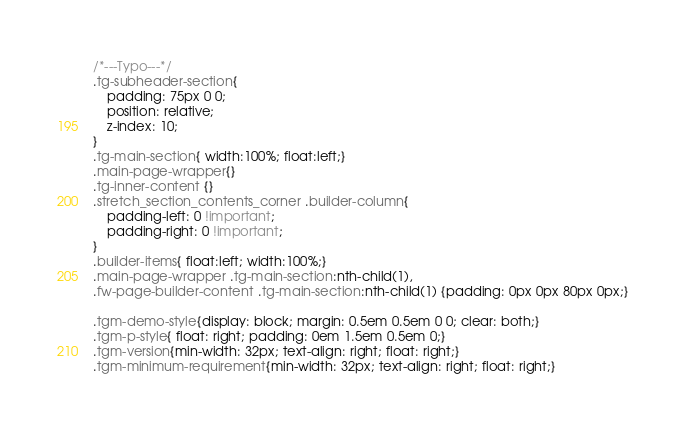Convert code to text. <code><loc_0><loc_0><loc_500><loc_500><_CSS_>/*---Typo---*/
.tg-subheader-section{
	padding: 75px 0 0;
	position: relative;
	z-index: 10;
}
.tg-main-section{ width:100%; float:left;}
.main-page-wrapper{}
.tg-inner-content {}
.stretch_section_contents_corner .builder-column{
	padding-left: 0 !important;
    padding-right: 0 !important;
}
.builder-items{ float:left; width:100%;}
.main-page-wrapper .tg-main-section:nth-child(1),
.fw-page-builder-content .tg-main-section:nth-child(1) {padding: 0px 0px 80px 0px;}

.tgm-demo-style{display: block; margin: 0.5em 0.5em 0 0; clear: both;}
.tgm-p-style{ float: right; padding: 0em 1.5em 0.5em 0;}
.tgm-version{min-width: 32px; text-align: right; float: right;}
.tgm-minimum-requirement{min-width: 32px; text-align: right; float: right;}</code> 